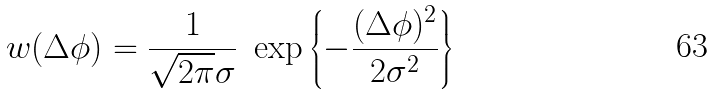Convert formula to latex. <formula><loc_0><loc_0><loc_500><loc_500>w ( \Delta \phi ) = \frac { 1 } { \sqrt { 2 \pi } \sigma } \ \exp \left \{ - \frac { ( \Delta \phi ) ^ { 2 } } { 2 \sigma ^ { 2 } } \right \}</formula> 